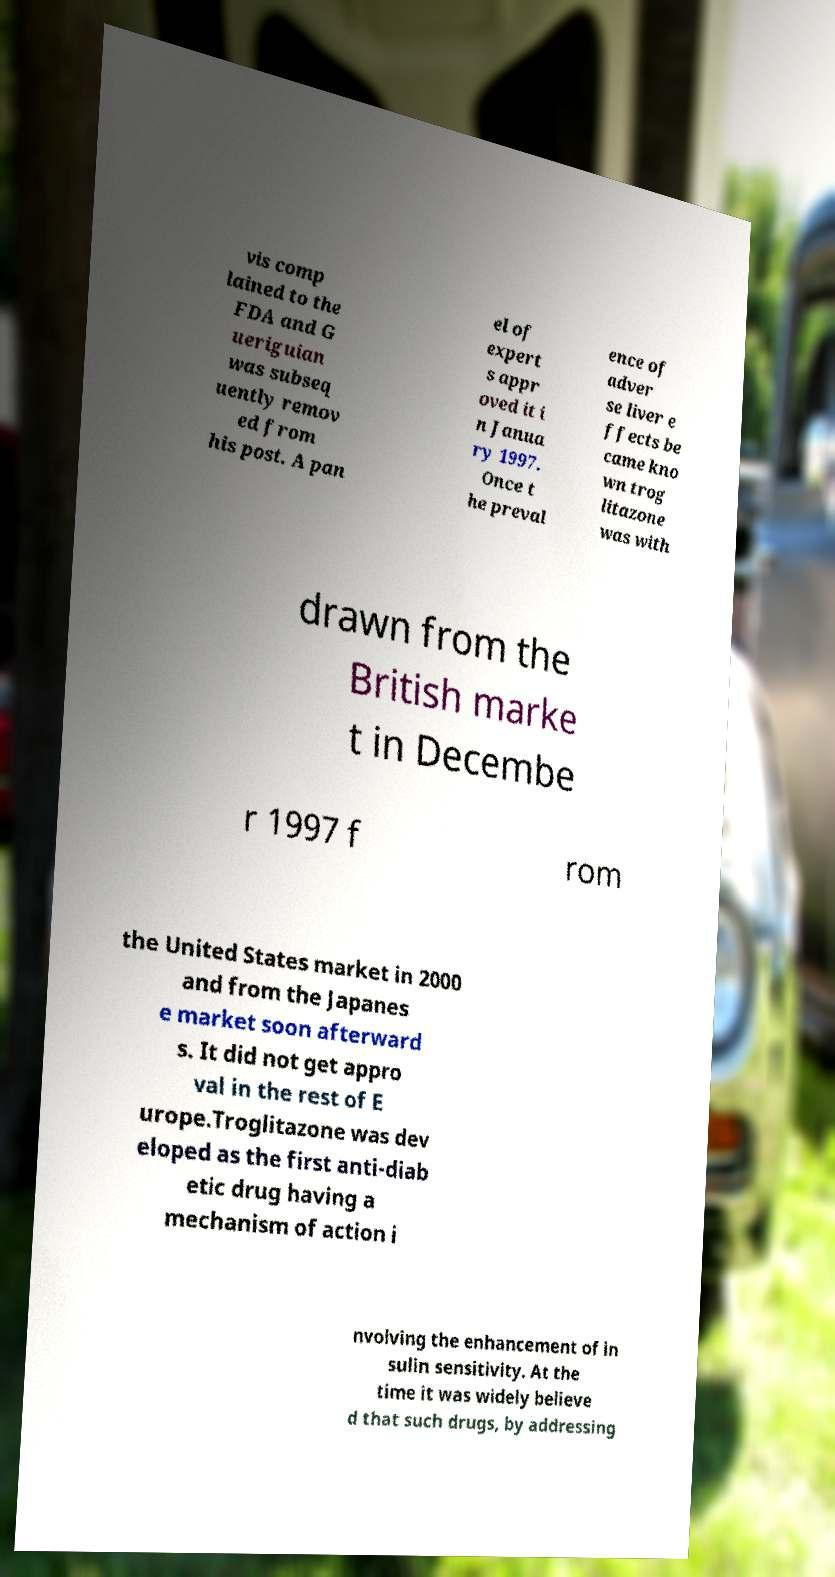I need the written content from this picture converted into text. Can you do that? vis comp lained to the FDA and G ueriguian was subseq uently remov ed from his post. A pan el of expert s appr oved it i n Janua ry 1997. Once t he preval ence of adver se liver e ffects be came kno wn trog litazone was with drawn from the British marke t in Decembe r 1997 f rom the United States market in 2000 and from the Japanes e market soon afterward s. It did not get appro val in the rest of E urope.Troglitazone was dev eloped as the first anti-diab etic drug having a mechanism of action i nvolving the enhancement of in sulin sensitivity. At the time it was widely believe d that such drugs, by addressing 